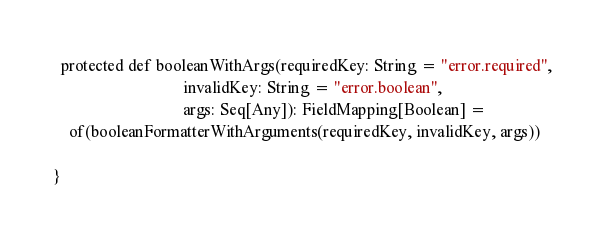Convert code to text. <code><loc_0><loc_0><loc_500><loc_500><_Scala_>  protected def booleanWithArgs(requiredKey: String = "error.required",
                                invalidKey: String = "error.boolean",
                                args: Seq[Any]): FieldMapping[Boolean] =
    of(booleanFormatterWithArguments(requiredKey, invalidKey, args))

}
</code> 